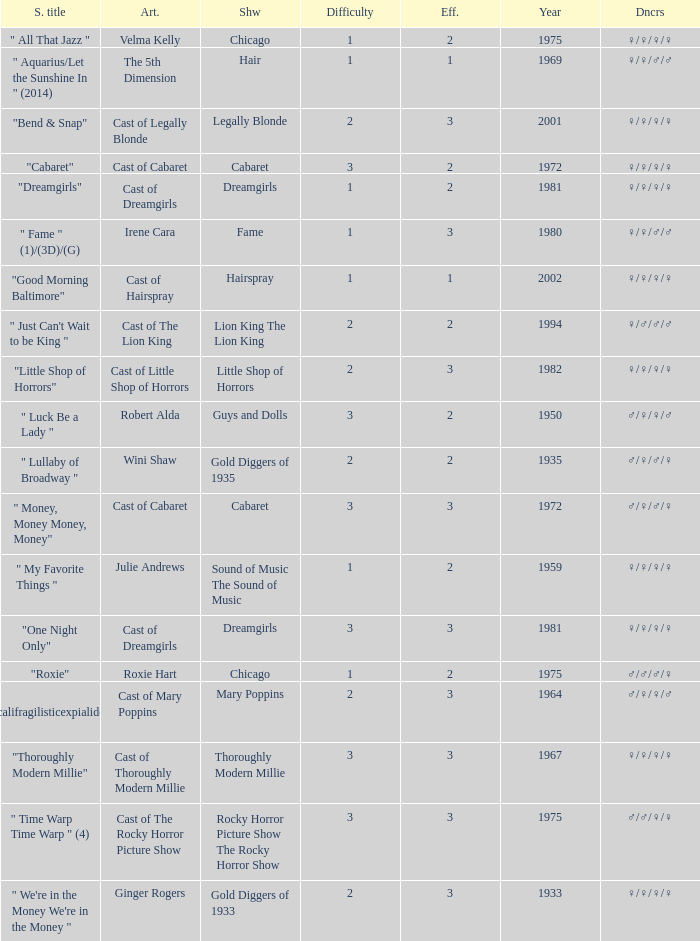What show featured the song "little shop of horrors"? Little Shop of Horrors. 